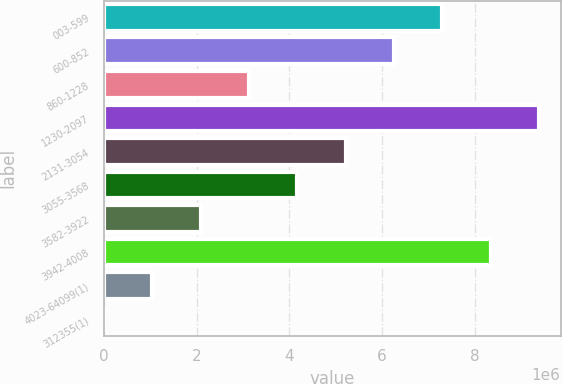Convert chart. <chart><loc_0><loc_0><loc_500><loc_500><bar_chart><fcel>003-599<fcel>600-852<fcel>860-1228<fcel>1230-2097<fcel>2131-3054<fcel>3055-3568<fcel>3582-3922<fcel>3942-4008<fcel>4023-64099(1)<fcel>312355(1)<nl><fcel>7.29694e+06<fcel>6.25461e+06<fcel>3.12761e+06<fcel>9.3816e+06<fcel>5.21227e+06<fcel>4.16994e+06<fcel>2.08528e+06<fcel>8.33927e+06<fcel>1.04295e+06<fcel>614<nl></chart> 